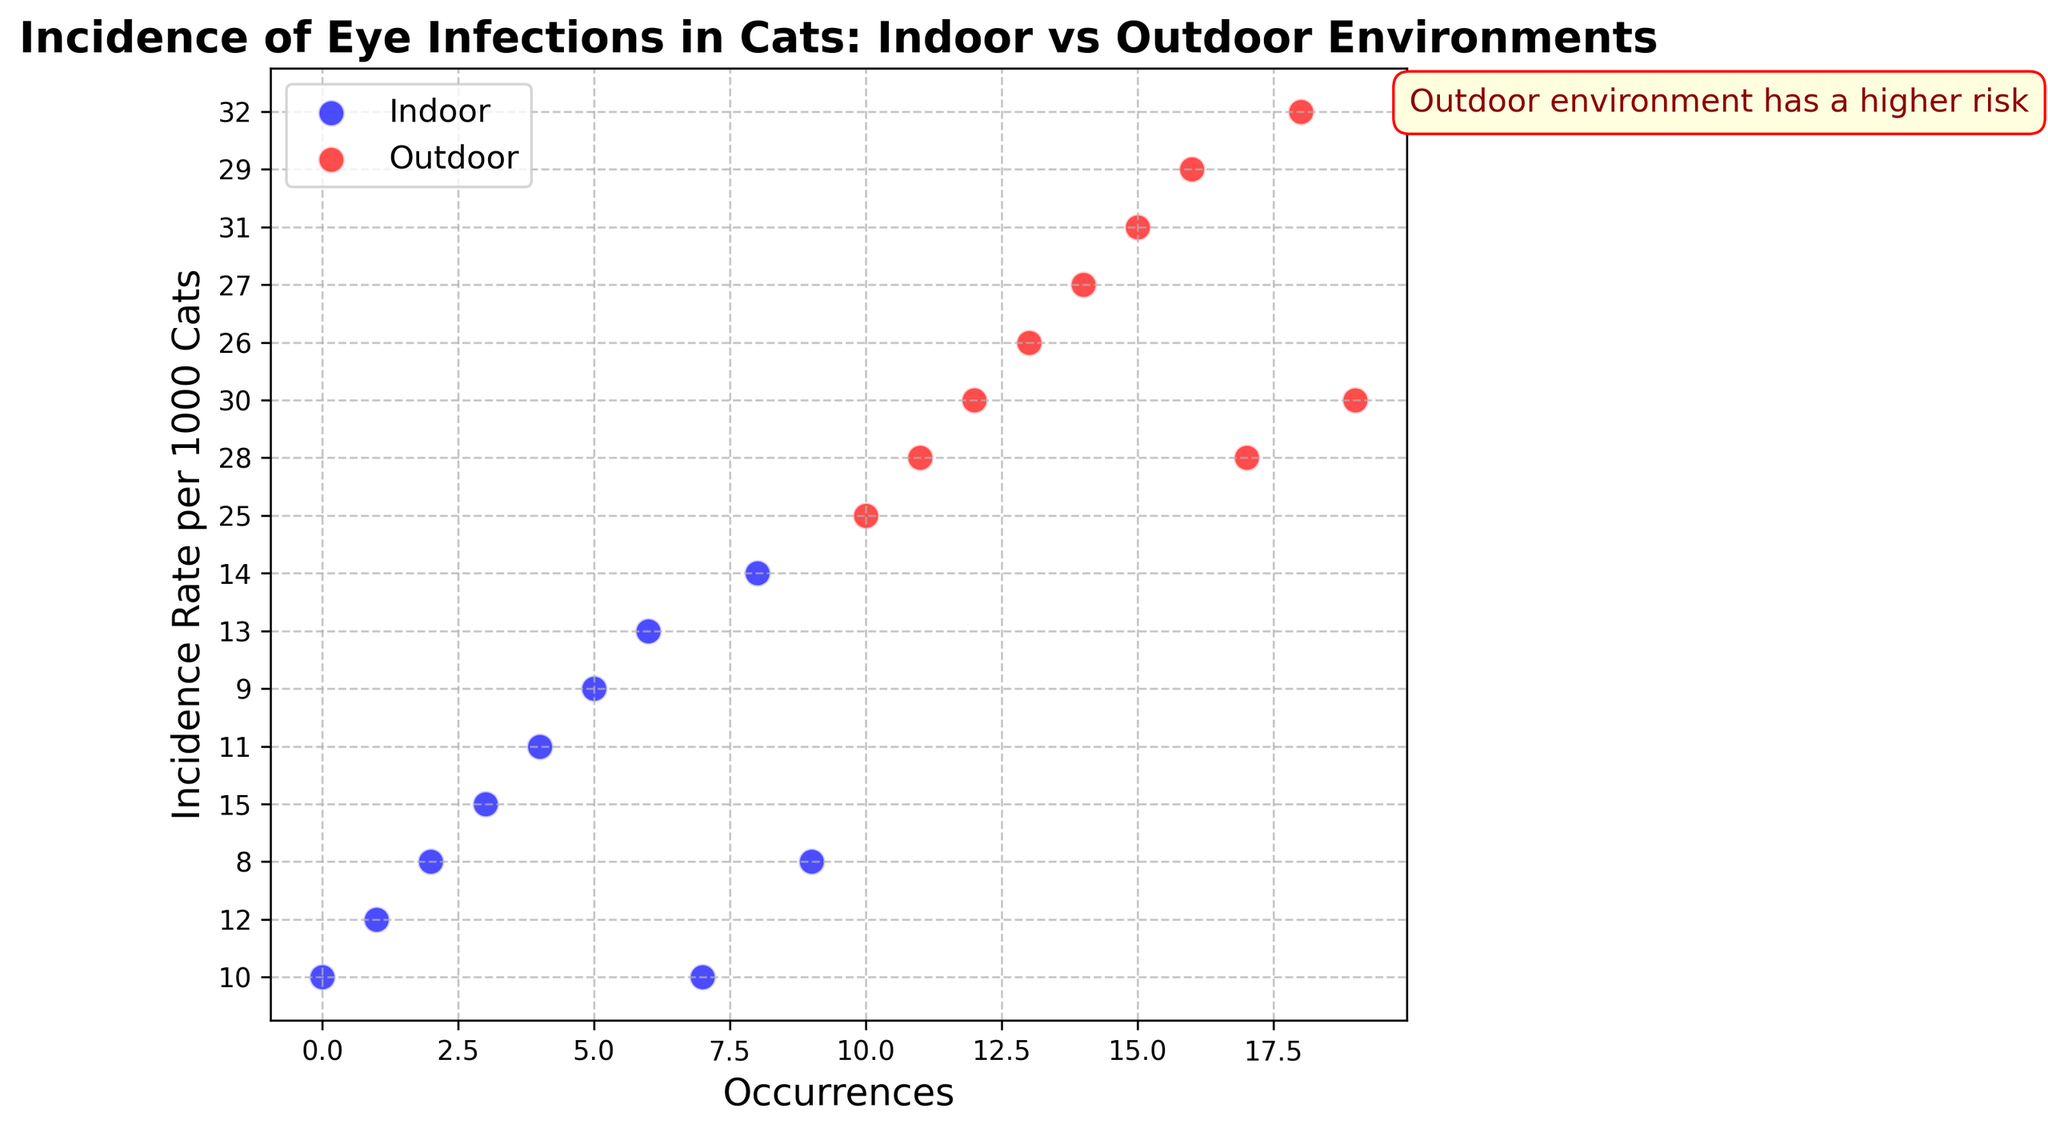What's the average incidence rate per 1000 cats for the outdoor environment? To calculate the average, sum all incidence rates for the outdoor environment (25 + 28 + 30 + 26 + 27 + 31 + 29 + 28 + 32 + 30) which totals to 286. There are 10 data points, so the average is 286/10 = 28.6
Answer: 28.6 Compare the highest incidence rate per 1000 cats between indoor and outdoor environments. Which one is higher? The highest incidence rate for the indoor environment is 15, while for the outdoor environment, it's 32. Comparing these two values, 32 is higher than 15.
Answer: Outdoor What is the range of incidence rates for indoor cats? To find the range, subtract the minimum incidence rate from the maximum incidence rate for indoor cats. The maximum is 15, and the minimum is 8. Therefore, the range is 15 - 8 = 7
Answer: 7 Do indoor or outdoor environments generally have a more consistent incidence rate for eye infections in cats? Examining the scatter plot, the indoor environment's rates range from 8 to 15, exhibiting less variation. The outdoor environment's rates range from 25 to 32, showing more variation. Hence, indoor environments have a more consistent incidence rate.
Answer: Indoor What is the difference between the average incidence rates of indoor and outdoor environments? First, calculate the average for indoor rates: (10 + 12 + 8 + 15 + 11 + 9 + 13 + 10 + 14 + 8) / 10 = 11. Then, find the average for outdoor rates which is 28.6. The difference is 28.6 - 11 = 17.6
Answer: 17.6 What does the text annotation signify about the environments in relation to the risk of eye infections? The annotation states "Outdoor environment has a higher risk," indicating that cats in outdoor environments have a higher incidence rate of eye infections compared to those in indoor environments.
Answer: Outdoor environment has a higher risk Compare the lowest incidence rates per 1000 cats between the indoor and outdoor environments. Which one is lower? The lowest incidence rate for indoor is 8 and for outdoor is 25. Since 8 is lower than 25, the indoor environment has the lower incidence rate.
Answer: Indoor What proportion of the total data points are from the outdoor environment? There are 20 total data points (10 indoor and 10 outdoor). The proportion from the outdoor environment is 10/20. Simplified, this is 1/2 or 50%.
Answer: 50% 